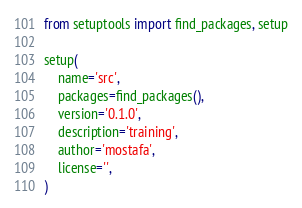<code> <loc_0><loc_0><loc_500><loc_500><_Python_>from setuptools import find_packages, setup

setup(
    name='src',
    packages=find_packages(),
    version='0.1.0',
    description='training',
    author='mostafa',
    license='',
)
</code> 